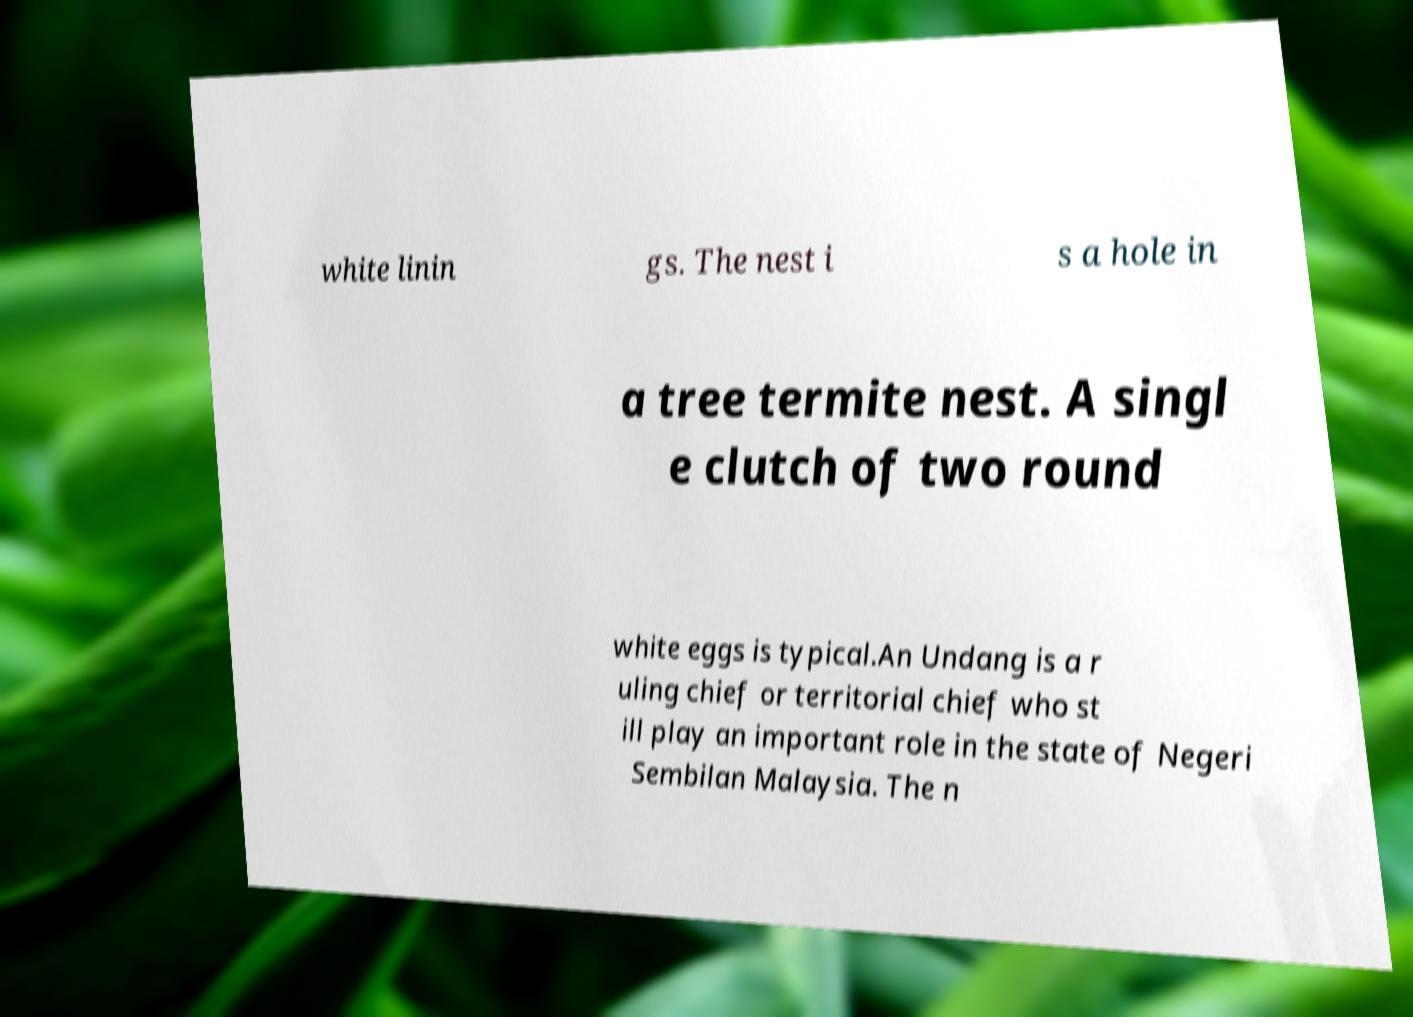Could you extract and type out the text from this image? white linin gs. The nest i s a hole in a tree termite nest. A singl e clutch of two round white eggs is typical.An Undang is a r uling chief or territorial chief who st ill play an important role in the state of Negeri Sembilan Malaysia. The n 